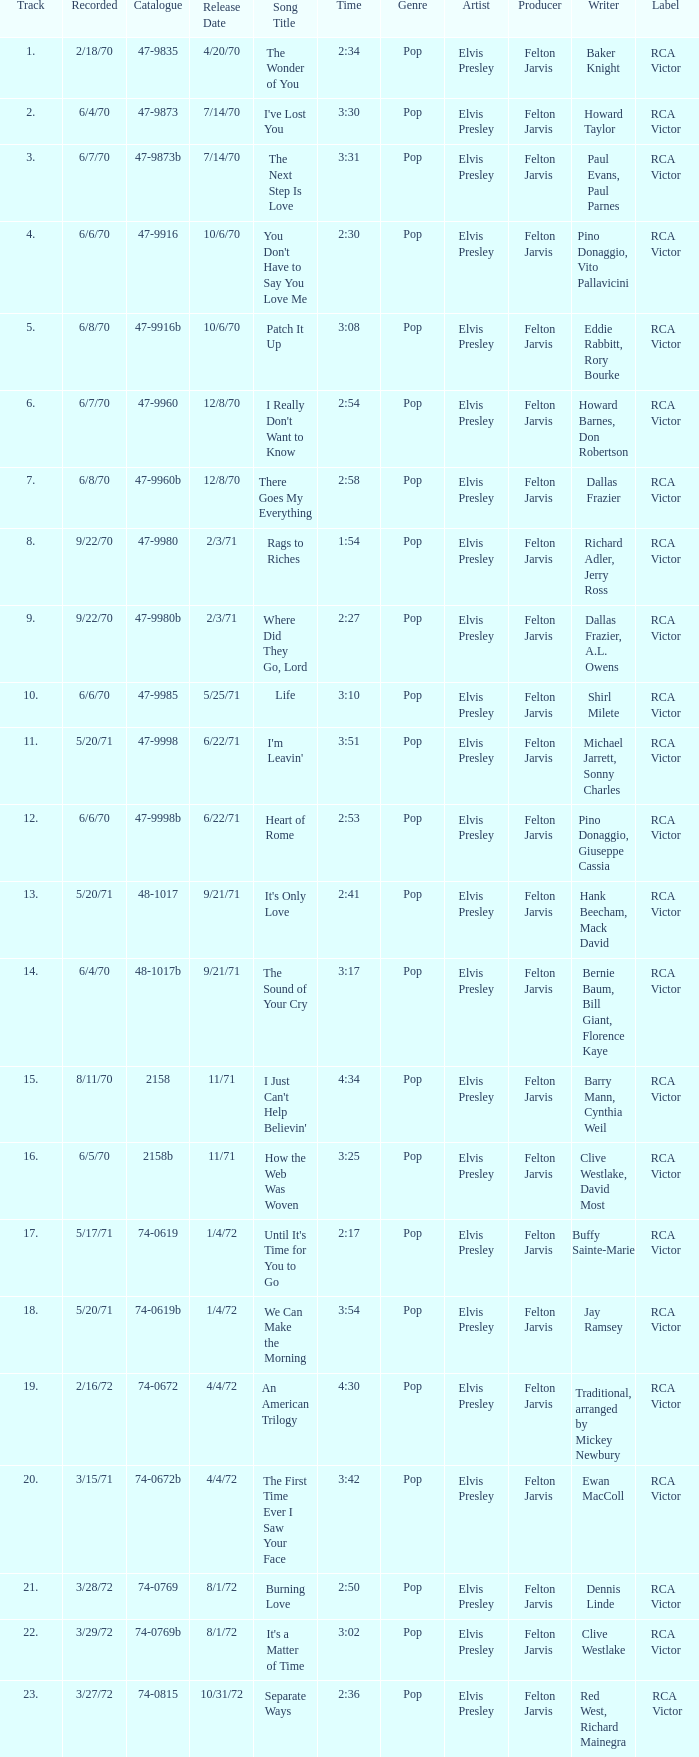What is the highest track for Burning Love? 21.0. 